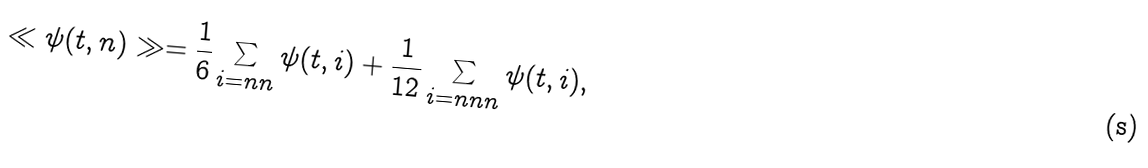<formula> <loc_0><loc_0><loc_500><loc_500>\ll \psi ( t , n ) \gg = \frac { 1 } { 6 } \sum _ { i = n n } \psi ( t , i ) + \frac { 1 } { 1 2 } \sum _ { i = n n n } \psi ( t , i ) ,</formula> 